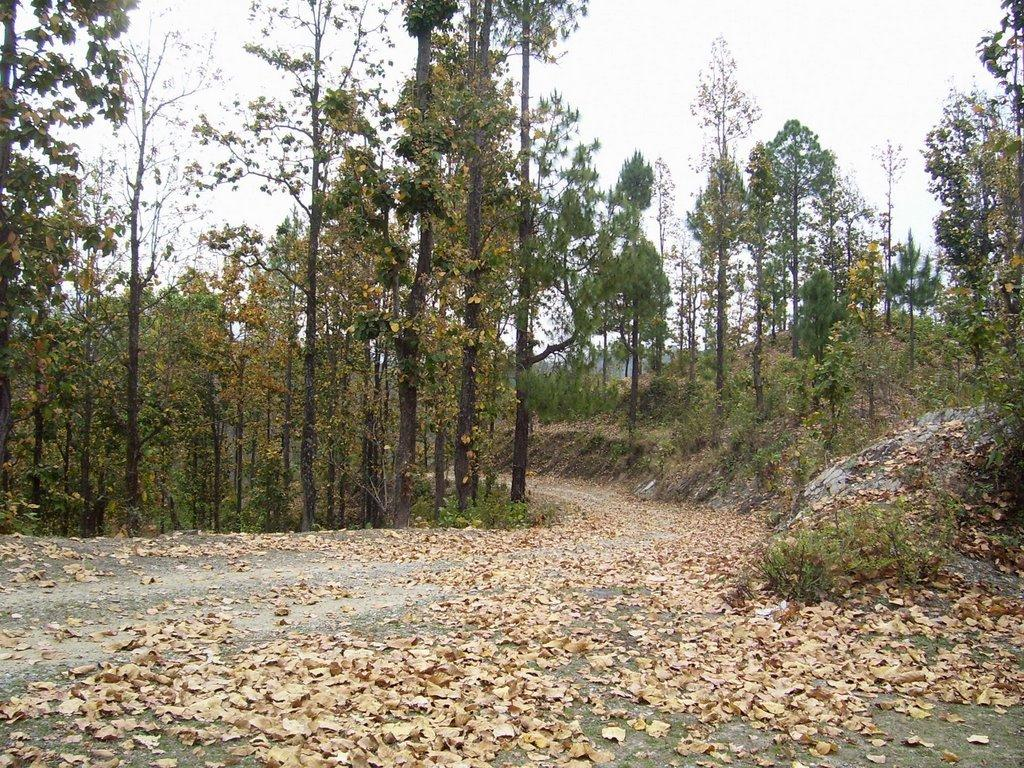What type of surface can be seen in the image? There is ground visible in the image. What can be found on the ground in the image? There are brown leaves on the ground. What type of pathway is present in the image? There is a road in the image. What surrounds the road in the image? There are trees on both sides of the road. What is visible in the background of the image? The sky is visible in the background of the image. Who is the owner of the finger seen in the image? There is no finger visible in the image, so it is not possible to determine the owner. 